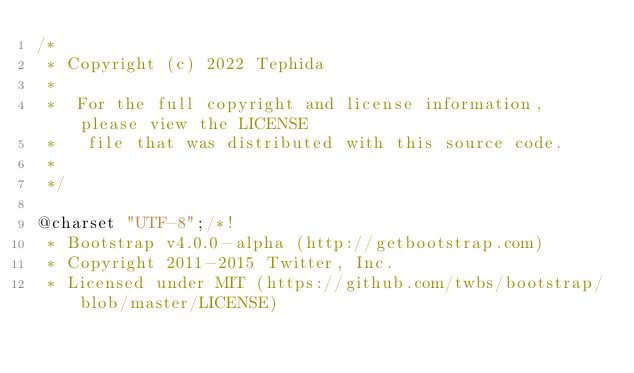Convert code to text. <code><loc_0><loc_0><loc_500><loc_500><_CSS_>/*
 * Copyright (c) 2022 Tephida
 *
 *  For the full copyright and license information, please view the LICENSE
 *   file that was distributed with this source code.
 *
 */

@charset "UTF-8";/*!
 * Bootstrap v4.0.0-alpha (http://getbootstrap.com)
 * Copyright 2011-2015 Twitter, Inc.
 * Licensed under MIT (https://github.com/twbs/bootstrap/blob/master/LICENSE)</code> 